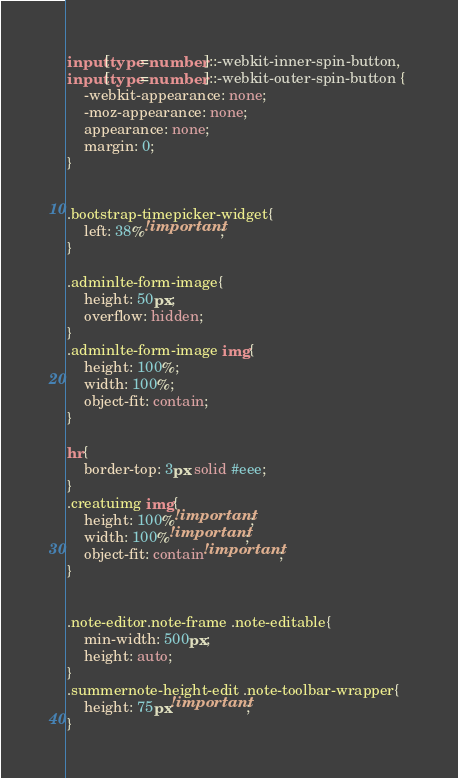Convert code to text. <code><loc_0><loc_0><loc_500><loc_500><_CSS_>input[type=number]::-webkit-inner-spin-button, 
input[type=number]::-webkit-outer-spin-button { 
	-webkit-appearance: none;
	-moz-appearance: none;
	appearance: none;
	margin: 0; 
}


.bootstrap-timepicker-widget{
	left: 38%!important;
}

.adminlte-form-image{
	height: 50px;
	overflow: hidden;
}
.adminlte-form-image img{
	height: 100%;
	width: 100%;
	object-fit: contain;
}

hr{
	border-top: 3px solid #eee;
}
.creatuimg img{
	height: 100%!important;
	width: 100%!important;
	object-fit: contain!important;
}


.note-editor.note-frame .note-editable{
	min-width: 500px;
	height: auto;
}
.summernote-height-edit .note-toolbar-wrapper{
	height: 75px!important;
}</code> 